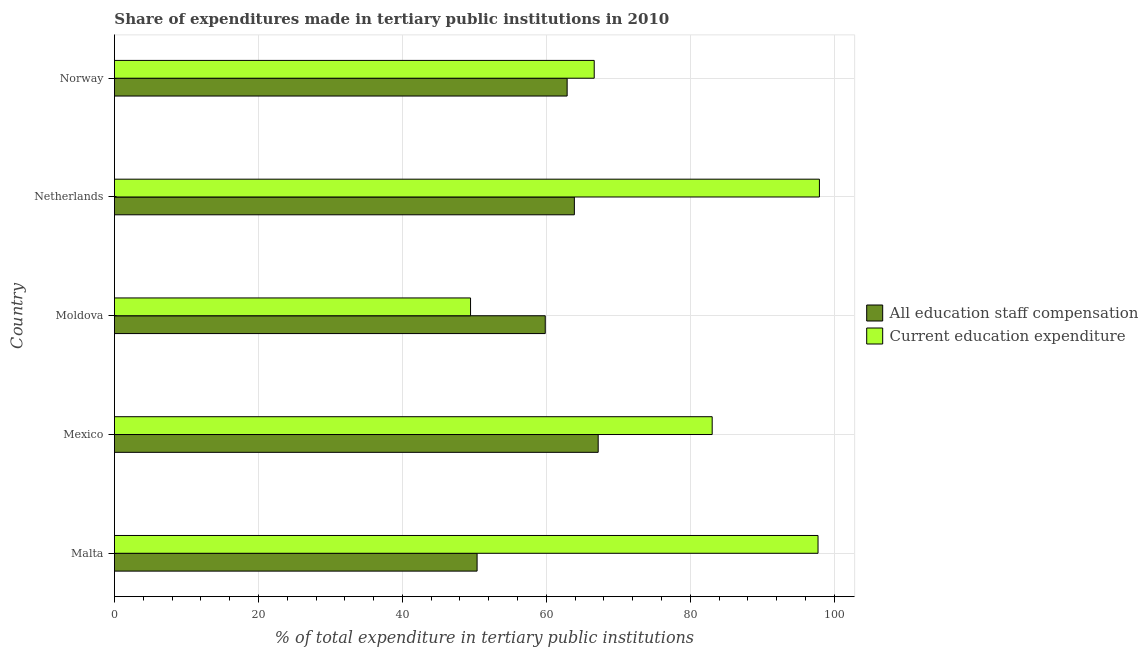How many different coloured bars are there?
Offer a terse response. 2. How many groups of bars are there?
Your answer should be compact. 5. Are the number of bars on each tick of the Y-axis equal?
Offer a very short reply. Yes. How many bars are there on the 3rd tick from the top?
Ensure brevity in your answer.  2. How many bars are there on the 1st tick from the bottom?
Provide a short and direct response. 2. What is the label of the 1st group of bars from the top?
Keep it short and to the point. Norway. What is the expenditure in education in Mexico?
Provide a succinct answer. 83.03. Across all countries, what is the maximum expenditure in education?
Your answer should be compact. 97.93. Across all countries, what is the minimum expenditure in staff compensation?
Give a very brief answer. 50.38. In which country was the expenditure in education maximum?
Provide a short and direct response. Netherlands. In which country was the expenditure in staff compensation minimum?
Provide a succinct answer. Malta. What is the total expenditure in staff compensation in the graph?
Offer a very short reply. 304.2. What is the difference between the expenditure in staff compensation in Mexico and that in Netherlands?
Your answer should be very brief. 3.31. What is the difference between the expenditure in education in Mexico and the expenditure in staff compensation in Moldova?
Your answer should be very brief. 23.19. What is the average expenditure in staff compensation per country?
Give a very brief answer. 60.84. What is the difference between the expenditure in education and expenditure in staff compensation in Mexico?
Keep it short and to the point. 15.84. In how many countries, is the expenditure in staff compensation greater than 12 %?
Provide a short and direct response. 5. What is the ratio of the expenditure in education in Moldova to that in Norway?
Your answer should be very brief. 0.74. What is the difference between the highest and the second highest expenditure in education?
Your answer should be very brief. 0.2. What is the difference between the highest and the lowest expenditure in education?
Ensure brevity in your answer.  48.46. What does the 1st bar from the top in Netherlands represents?
Ensure brevity in your answer.  Current education expenditure. What does the 1st bar from the bottom in Moldova represents?
Make the answer very short. All education staff compensation. How many bars are there?
Your answer should be compact. 10. What is the difference between two consecutive major ticks on the X-axis?
Give a very brief answer. 20. Does the graph contain any zero values?
Make the answer very short. No. How many legend labels are there?
Your answer should be very brief. 2. How are the legend labels stacked?
Offer a terse response. Vertical. What is the title of the graph?
Ensure brevity in your answer.  Share of expenditures made in tertiary public institutions in 2010. Does "Highest 20% of population" appear as one of the legend labels in the graph?
Provide a succinct answer. No. What is the label or title of the X-axis?
Offer a terse response. % of total expenditure in tertiary public institutions. What is the label or title of the Y-axis?
Offer a very short reply. Country. What is the % of total expenditure in tertiary public institutions of All education staff compensation in Malta?
Give a very brief answer. 50.38. What is the % of total expenditure in tertiary public institutions in Current education expenditure in Malta?
Keep it short and to the point. 97.74. What is the % of total expenditure in tertiary public institutions in All education staff compensation in Mexico?
Offer a terse response. 67.2. What is the % of total expenditure in tertiary public institutions of Current education expenditure in Mexico?
Your response must be concise. 83.03. What is the % of total expenditure in tertiary public institutions in All education staff compensation in Moldova?
Offer a terse response. 59.85. What is the % of total expenditure in tertiary public institutions of Current education expenditure in Moldova?
Give a very brief answer. 49.47. What is the % of total expenditure in tertiary public institutions of All education staff compensation in Netherlands?
Your answer should be very brief. 63.89. What is the % of total expenditure in tertiary public institutions in Current education expenditure in Netherlands?
Your response must be concise. 97.93. What is the % of total expenditure in tertiary public institutions of All education staff compensation in Norway?
Give a very brief answer. 62.89. What is the % of total expenditure in tertiary public institutions in Current education expenditure in Norway?
Provide a succinct answer. 66.65. Across all countries, what is the maximum % of total expenditure in tertiary public institutions of All education staff compensation?
Ensure brevity in your answer.  67.2. Across all countries, what is the maximum % of total expenditure in tertiary public institutions of Current education expenditure?
Provide a succinct answer. 97.93. Across all countries, what is the minimum % of total expenditure in tertiary public institutions in All education staff compensation?
Make the answer very short. 50.38. Across all countries, what is the minimum % of total expenditure in tertiary public institutions in Current education expenditure?
Make the answer very short. 49.47. What is the total % of total expenditure in tertiary public institutions of All education staff compensation in the graph?
Make the answer very short. 304.2. What is the total % of total expenditure in tertiary public institutions in Current education expenditure in the graph?
Offer a terse response. 394.82. What is the difference between the % of total expenditure in tertiary public institutions of All education staff compensation in Malta and that in Mexico?
Your answer should be compact. -16.82. What is the difference between the % of total expenditure in tertiary public institutions in Current education expenditure in Malta and that in Mexico?
Offer a terse response. 14.7. What is the difference between the % of total expenditure in tertiary public institutions in All education staff compensation in Malta and that in Moldova?
Provide a succinct answer. -9.47. What is the difference between the % of total expenditure in tertiary public institutions of Current education expenditure in Malta and that in Moldova?
Your response must be concise. 48.27. What is the difference between the % of total expenditure in tertiary public institutions of All education staff compensation in Malta and that in Netherlands?
Make the answer very short. -13.51. What is the difference between the % of total expenditure in tertiary public institutions in Current education expenditure in Malta and that in Netherlands?
Your answer should be very brief. -0.19. What is the difference between the % of total expenditure in tertiary public institutions in All education staff compensation in Malta and that in Norway?
Give a very brief answer. -12.51. What is the difference between the % of total expenditure in tertiary public institutions of Current education expenditure in Malta and that in Norway?
Offer a very short reply. 31.09. What is the difference between the % of total expenditure in tertiary public institutions of All education staff compensation in Mexico and that in Moldova?
Your answer should be compact. 7.35. What is the difference between the % of total expenditure in tertiary public institutions of Current education expenditure in Mexico and that in Moldova?
Your answer should be very brief. 33.57. What is the difference between the % of total expenditure in tertiary public institutions of All education staff compensation in Mexico and that in Netherlands?
Provide a short and direct response. 3.31. What is the difference between the % of total expenditure in tertiary public institutions in Current education expenditure in Mexico and that in Netherlands?
Your response must be concise. -14.9. What is the difference between the % of total expenditure in tertiary public institutions of All education staff compensation in Mexico and that in Norway?
Provide a succinct answer. 4.31. What is the difference between the % of total expenditure in tertiary public institutions of Current education expenditure in Mexico and that in Norway?
Keep it short and to the point. 16.39. What is the difference between the % of total expenditure in tertiary public institutions of All education staff compensation in Moldova and that in Netherlands?
Make the answer very short. -4.04. What is the difference between the % of total expenditure in tertiary public institutions in Current education expenditure in Moldova and that in Netherlands?
Your answer should be compact. -48.46. What is the difference between the % of total expenditure in tertiary public institutions of All education staff compensation in Moldova and that in Norway?
Keep it short and to the point. -3.04. What is the difference between the % of total expenditure in tertiary public institutions in Current education expenditure in Moldova and that in Norway?
Make the answer very short. -17.18. What is the difference between the % of total expenditure in tertiary public institutions of Current education expenditure in Netherlands and that in Norway?
Ensure brevity in your answer.  31.28. What is the difference between the % of total expenditure in tertiary public institutions of All education staff compensation in Malta and the % of total expenditure in tertiary public institutions of Current education expenditure in Mexico?
Provide a succinct answer. -32.66. What is the difference between the % of total expenditure in tertiary public institutions in All education staff compensation in Malta and the % of total expenditure in tertiary public institutions in Current education expenditure in Moldova?
Your response must be concise. 0.91. What is the difference between the % of total expenditure in tertiary public institutions in All education staff compensation in Malta and the % of total expenditure in tertiary public institutions in Current education expenditure in Netherlands?
Provide a short and direct response. -47.55. What is the difference between the % of total expenditure in tertiary public institutions in All education staff compensation in Malta and the % of total expenditure in tertiary public institutions in Current education expenditure in Norway?
Your answer should be compact. -16.27. What is the difference between the % of total expenditure in tertiary public institutions of All education staff compensation in Mexico and the % of total expenditure in tertiary public institutions of Current education expenditure in Moldova?
Keep it short and to the point. 17.73. What is the difference between the % of total expenditure in tertiary public institutions of All education staff compensation in Mexico and the % of total expenditure in tertiary public institutions of Current education expenditure in Netherlands?
Offer a terse response. -30.73. What is the difference between the % of total expenditure in tertiary public institutions of All education staff compensation in Mexico and the % of total expenditure in tertiary public institutions of Current education expenditure in Norway?
Ensure brevity in your answer.  0.55. What is the difference between the % of total expenditure in tertiary public institutions in All education staff compensation in Moldova and the % of total expenditure in tertiary public institutions in Current education expenditure in Netherlands?
Give a very brief answer. -38.09. What is the difference between the % of total expenditure in tertiary public institutions in All education staff compensation in Moldova and the % of total expenditure in tertiary public institutions in Current education expenditure in Norway?
Your response must be concise. -6.8. What is the difference between the % of total expenditure in tertiary public institutions of All education staff compensation in Netherlands and the % of total expenditure in tertiary public institutions of Current education expenditure in Norway?
Provide a succinct answer. -2.76. What is the average % of total expenditure in tertiary public institutions of All education staff compensation per country?
Provide a succinct answer. 60.84. What is the average % of total expenditure in tertiary public institutions of Current education expenditure per country?
Provide a short and direct response. 78.96. What is the difference between the % of total expenditure in tertiary public institutions in All education staff compensation and % of total expenditure in tertiary public institutions in Current education expenditure in Malta?
Make the answer very short. -47.36. What is the difference between the % of total expenditure in tertiary public institutions in All education staff compensation and % of total expenditure in tertiary public institutions in Current education expenditure in Mexico?
Provide a succinct answer. -15.84. What is the difference between the % of total expenditure in tertiary public institutions of All education staff compensation and % of total expenditure in tertiary public institutions of Current education expenditure in Moldova?
Make the answer very short. 10.38. What is the difference between the % of total expenditure in tertiary public institutions of All education staff compensation and % of total expenditure in tertiary public institutions of Current education expenditure in Netherlands?
Your answer should be compact. -34.04. What is the difference between the % of total expenditure in tertiary public institutions in All education staff compensation and % of total expenditure in tertiary public institutions in Current education expenditure in Norway?
Offer a terse response. -3.76. What is the ratio of the % of total expenditure in tertiary public institutions in All education staff compensation in Malta to that in Mexico?
Ensure brevity in your answer.  0.75. What is the ratio of the % of total expenditure in tertiary public institutions in Current education expenditure in Malta to that in Mexico?
Give a very brief answer. 1.18. What is the ratio of the % of total expenditure in tertiary public institutions of All education staff compensation in Malta to that in Moldova?
Offer a very short reply. 0.84. What is the ratio of the % of total expenditure in tertiary public institutions in Current education expenditure in Malta to that in Moldova?
Your answer should be very brief. 1.98. What is the ratio of the % of total expenditure in tertiary public institutions of All education staff compensation in Malta to that in Netherlands?
Your response must be concise. 0.79. What is the ratio of the % of total expenditure in tertiary public institutions of Current education expenditure in Malta to that in Netherlands?
Your answer should be compact. 1. What is the ratio of the % of total expenditure in tertiary public institutions in All education staff compensation in Malta to that in Norway?
Your answer should be compact. 0.8. What is the ratio of the % of total expenditure in tertiary public institutions of Current education expenditure in Malta to that in Norway?
Provide a succinct answer. 1.47. What is the ratio of the % of total expenditure in tertiary public institutions of All education staff compensation in Mexico to that in Moldova?
Your response must be concise. 1.12. What is the ratio of the % of total expenditure in tertiary public institutions of Current education expenditure in Mexico to that in Moldova?
Give a very brief answer. 1.68. What is the ratio of the % of total expenditure in tertiary public institutions of All education staff compensation in Mexico to that in Netherlands?
Make the answer very short. 1.05. What is the ratio of the % of total expenditure in tertiary public institutions in Current education expenditure in Mexico to that in Netherlands?
Make the answer very short. 0.85. What is the ratio of the % of total expenditure in tertiary public institutions in All education staff compensation in Mexico to that in Norway?
Offer a very short reply. 1.07. What is the ratio of the % of total expenditure in tertiary public institutions of Current education expenditure in Mexico to that in Norway?
Give a very brief answer. 1.25. What is the ratio of the % of total expenditure in tertiary public institutions of All education staff compensation in Moldova to that in Netherlands?
Provide a succinct answer. 0.94. What is the ratio of the % of total expenditure in tertiary public institutions in Current education expenditure in Moldova to that in Netherlands?
Ensure brevity in your answer.  0.51. What is the ratio of the % of total expenditure in tertiary public institutions in All education staff compensation in Moldova to that in Norway?
Offer a very short reply. 0.95. What is the ratio of the % of total expenditure in tertiary public institutions in Current education expenditure in Moldova to that in Norway?
Give a very brief answer. 0.74. What is the ratio of the % of total expenditure in tertiary public institutions in All education staff compensation in Netherlands to that in Norway?
Offer a very short reply. 1.02. What is the ratio of the % of total expenditure in tertiary public institutions of Current education expenditure in Netherlands to that in Norway?
Offer a terse response. 1.47. What is the difference between the highest and the second highest % of total expenditure in tertiary public institutions of All education staff compensation?
Keep it short and to the point. 3.31. What is the difference between the highest and the second highest % of total expenditure in tertiary public institutions in Current education expenditure?
Your response must be concise. 0.19. What is the difference between the highest and the lowest % of total expenditure in tertiary public institutions of All education staff compensation?
Give a very brief answer. 16.82. What is the difference between the highest and the lowest % of total expenditure in tertiary public institutions of Current education expenditure?
Provide a succinct answer. 48.46. 